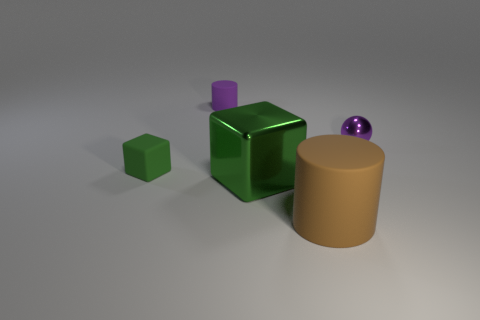Subtract all red cylinders. Subtract all purple spheres. How many cylinders are left? 2 Add 2 small purple objects. How many objects exist? 7 Subtract all cylinders. How many objects are left? 3 Subtract 1 purple cylinders. How many objects are left? 4 Subtract all small purple cylinders. Subtract all purple shiny balls. How many objects are left? 3 Add 1 big green objects. How many big green objects are left? 2 Add 4 small purple cylinders. How many small purple cylinders exist? 5 